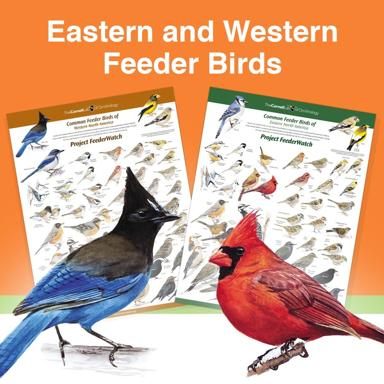What are some unique features to look for in Eastern birds compared to Western birds? When comparing Eastern to Western birds, focus on unique features such as color patterns, beak shape, and size. Eastern birds often exhibit brighter and more varied plumage which can be pivotal for survival in dense woodland areas, whereas Western birds might have features adapted to open and arid environments, like lighter coloration to reflect sunlight and broader wings for soaring over vast spaces. 